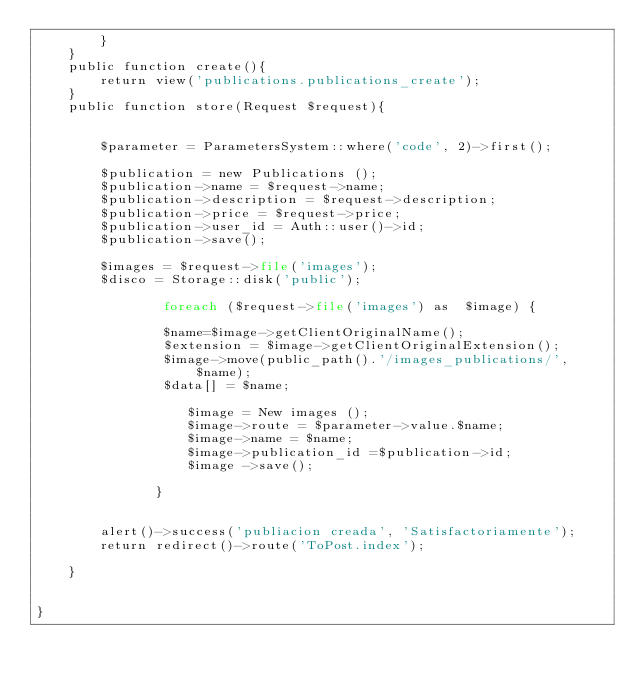<code> <loc_0><loc_0><loc_500><loc_500><_PHP_>        }
    }
    public function create(){
        return view('publications.publications_create');
    }
    public function store(Request $request){
        

        $parameter = ParametersSystem::where('code', 2)->first(); 

    	$publication = new Publications ();
        $publication->name = $request->name;
        $publication->description = $request->description;
        $publication->price = $request->price;
        $publication->user_id = Auth::user()->id;
        $publication->save();

        $images = $request->file('images');
        $disco = Storage::disk('public');

          	    foreach ($request->file('images') as  $image) {

          	    $name=$image->getClientOriginalName();
          	    $extension = $image->getClientOriginalExtension();
                $image->move(public_path().'/images_publications/', $name);  
                $data[] = $name;
          	       
		           $image = New images ();
		           $image->route = $parameter->value.$name;
		           $image->name = $name;
		           $image->publication_id =$publication->id; 
		           $image ->save();

		       }


        alert()->success('publiacion creada', 'Satisfactoriamente');
        return redirect()->route('ToPost.index');

    }


}
</code> 